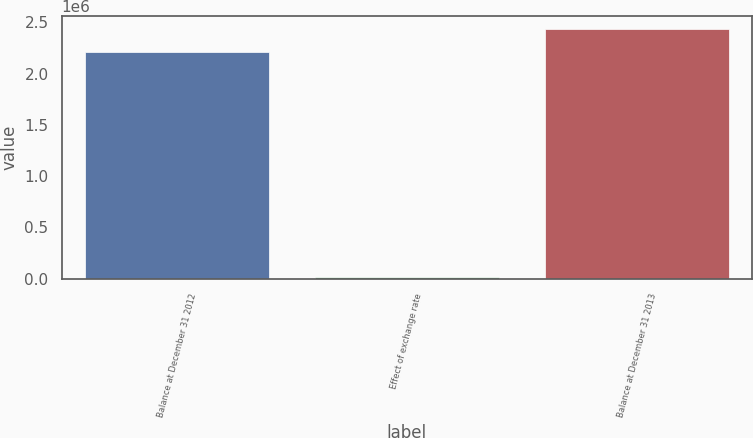<chart> <loc_0><loc_0><loc_500><loc_500><bar_chart><fcel>Balance at December 31 2012<fcel>Effect of exchange rate<fcel>Balance at December 31 2013<nl><fcel>2.21095e+06<fcel>17134<fcel>2.4374e+06<nl></chart> 